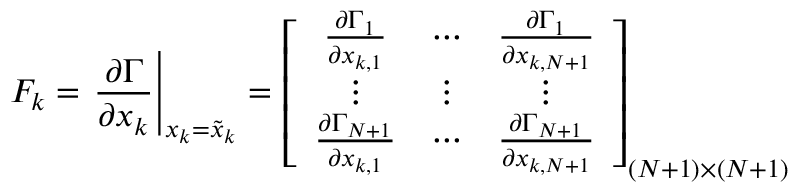<formula> <loc_0><loc_0><loc_500><loc_500>F _ { k } = \frac { \partial \Gamma } { \partial x _ { k } } \right | _ { x _ { k } = \tilde { x } _ { k } } = \left [ \begin{array} { c c c } { \frac { \partial \Gamma _ { 1 } } { \partial x _ { k , 1 } } } & { \cdots } & { \frac { \partial \Gamma _ { 1 } } { \partial x _ { k , N + 1 } } } \\ { \vdots } & { \vdots } & { \vdots } \\ { \frac { \partial \Gamma _ { N + 1 } } { \partial x _ { k , 1 } } } & { \cdots } & { \frac { \partial \Gamma _ { N + 1 } } { \partial x _ { k , N + 1 } } } \end{array} \right ] _ { ( N + 1 ) \times ( N + 1 ) }</formula> 